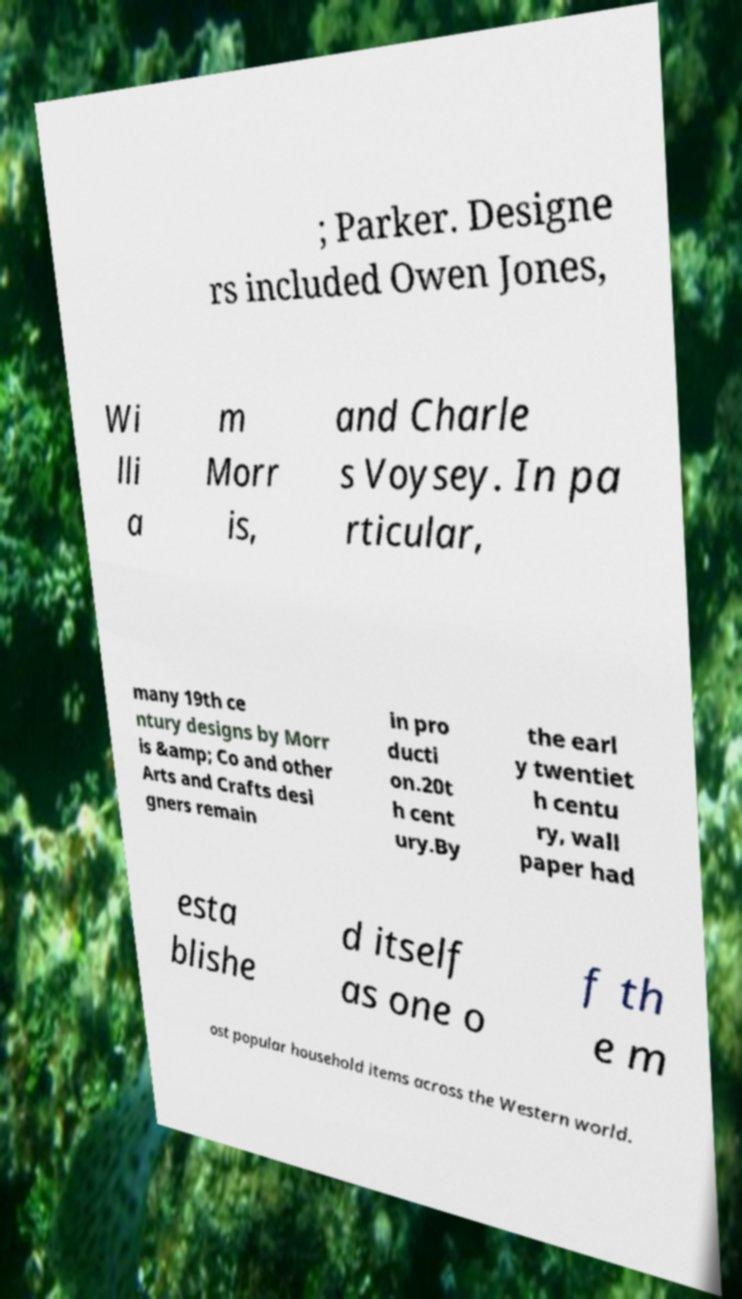I need the written content from this picture converted into text. Can you do that? ; Parker. Designe rs included Owen Jones, Wi lli a m Morr is, and Charle s Voysey. In pa rticular, many 19th ce ntury designs by Morr is &amp; Co and other Arts and Crafts desi gners remain in pro ducti on.20t h cent ury.By the earl y twentiet h centu ry, wall paper had esta blishe d itself as one o f th e m ost popular household items across the Western world. 